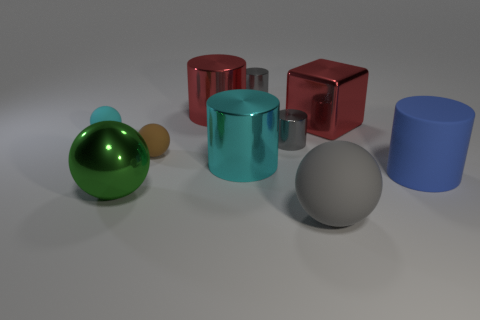Subtract all rubber spheres. How many spheres are left? 1 Subtract all red cylinders. How many cylinders are left? 4 Subtract all yellow cylinders. How many gray spheres are left? 1 Subtract 0 brown cylinders. How many objects are left? 10 Subtract all blocks. How many objects are left? 9 Subtract 1 cylinders. How many cylinders are left? 4 Subtract all purple cylinders. Subtract all yellow balls. How many cylinders are left? 5 Subtract all shiny cylinders. Subtract all big red cylinders. How many objects are left? 5 Add 7 cyan rubber things. How many cyan rubber things are left? 8 Add 3 metallic cylinders. How many metallic cylinders exist? 7 